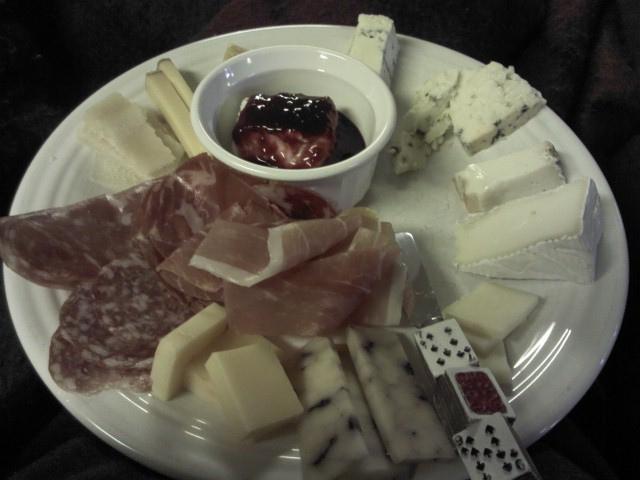What color is the back of the playing card printed cheese wedge?
Select the accurate response from the four choices given to answer the question.
Options: Blue, green, red, purple. Red. 